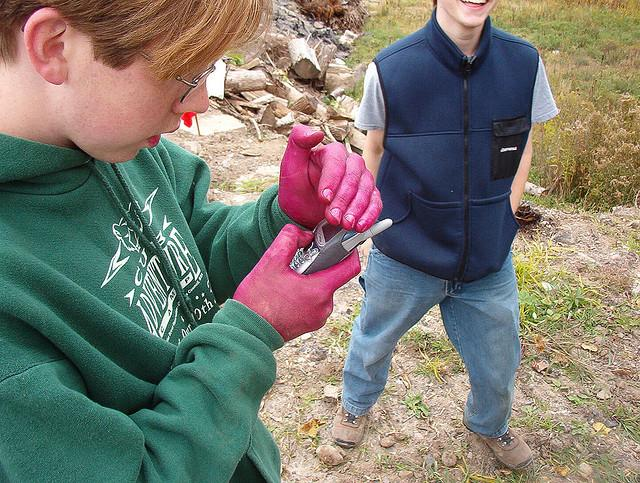Why is the boy blocking the view of his phone? Please explain your reasoning. visibility. He is doing that so he can see it and no one else can. 